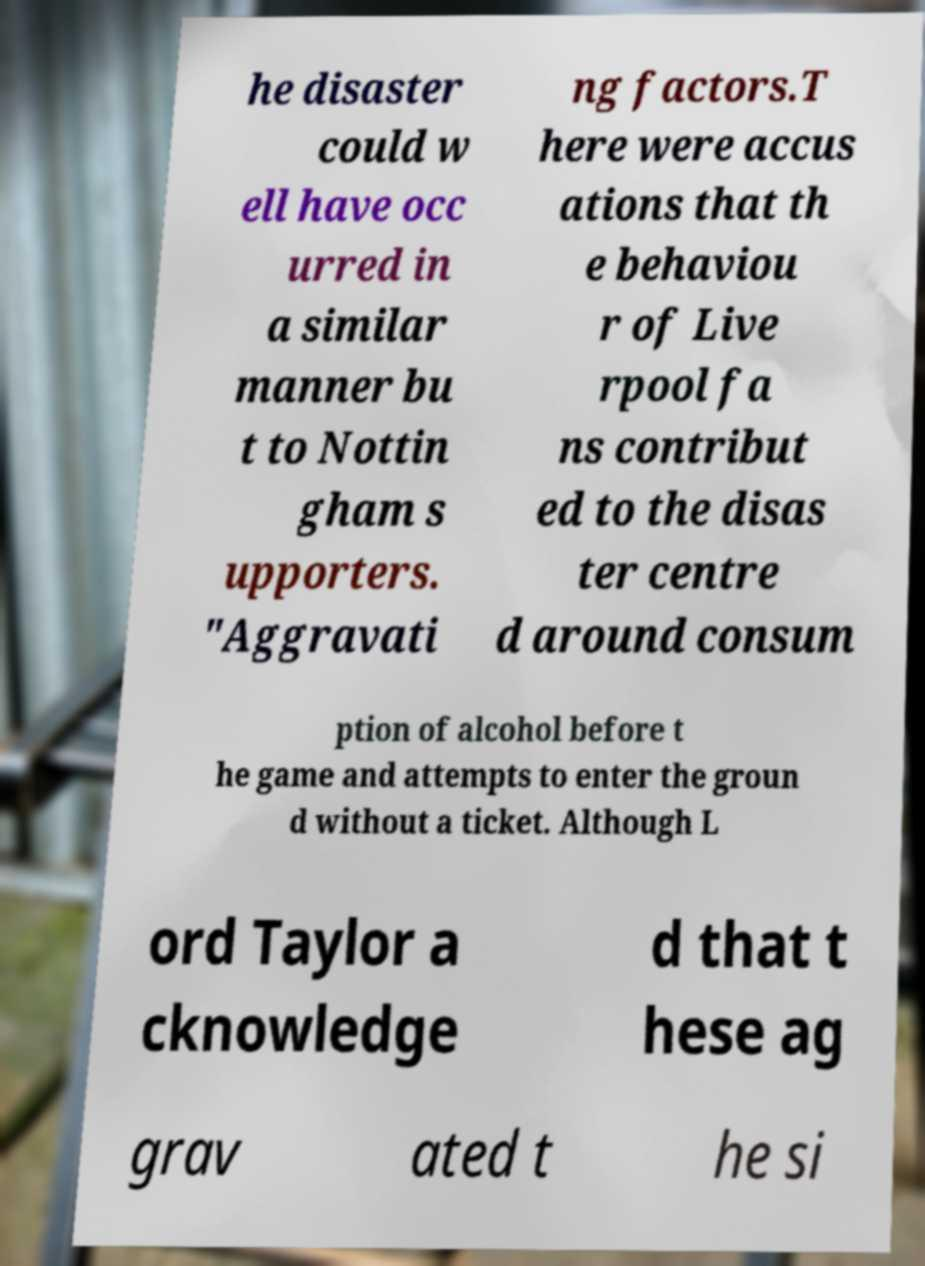What messages or text are displayed in this image? I need them in a readable, typed format. he disaster could w ell have occ urred in a similar manner bu t to Nottin gham s upporters. "Aggravati ng factors.T here were accus ations that th e behaviou r of Live rpool fa ns contribut ed to the disas ter centre d around consum ption of alcohol before t he game and attempts to enter the groun d without a ticket. Although L ord Taylor a cknowledge d that t hese ag grav ated t he si 